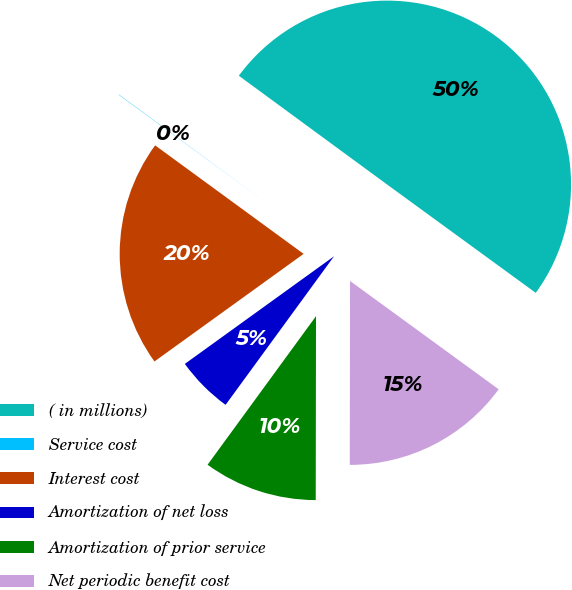Convert chart to OTSL. <chart><loc_0><loc_0><loc_500><loc_500><pie_chart><fcel>( in millions)<fcel>Service cost<fcel>Interest cost<fcel>Amortization of net loss<fcel>Amortization of prior service<fcel>Net periodic benefit cost<nl><fcel>49.95%<fcel>0.03%<fcel>19.99%<fcel>5.02%<fcel>10.01%<fcel>15.0%<nl></chart> 